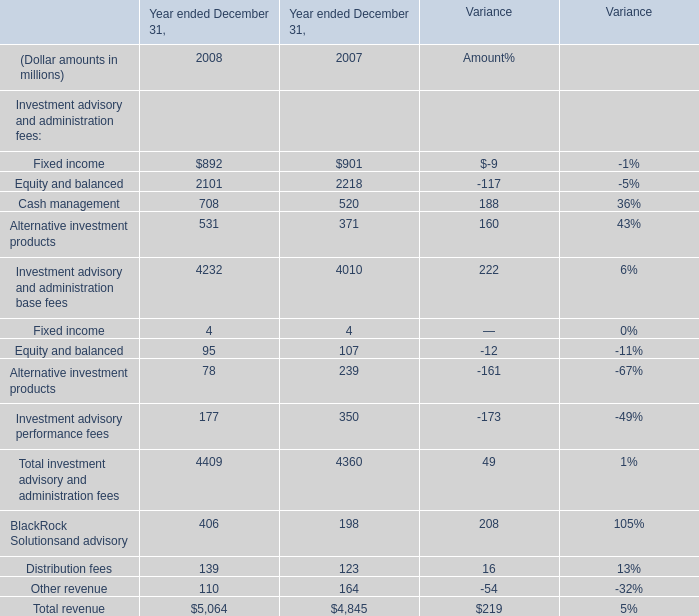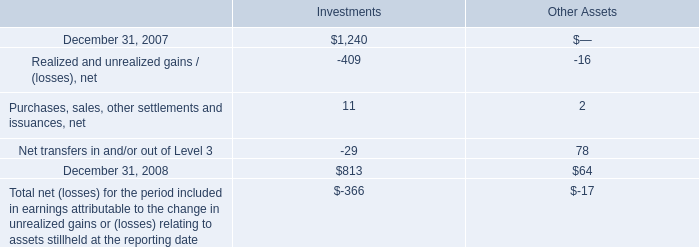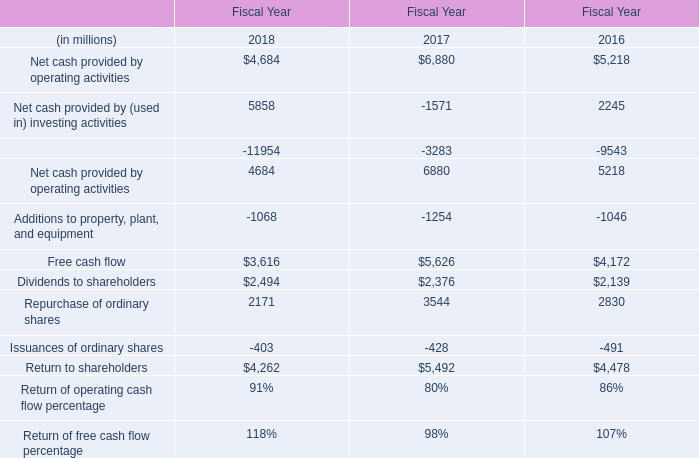In the year with the most Cash management in table 0, what is the growth rate of Alternative investment products in table 2? 
Computations: ((531 - 371) / 371)
Answer: 0.43127. 